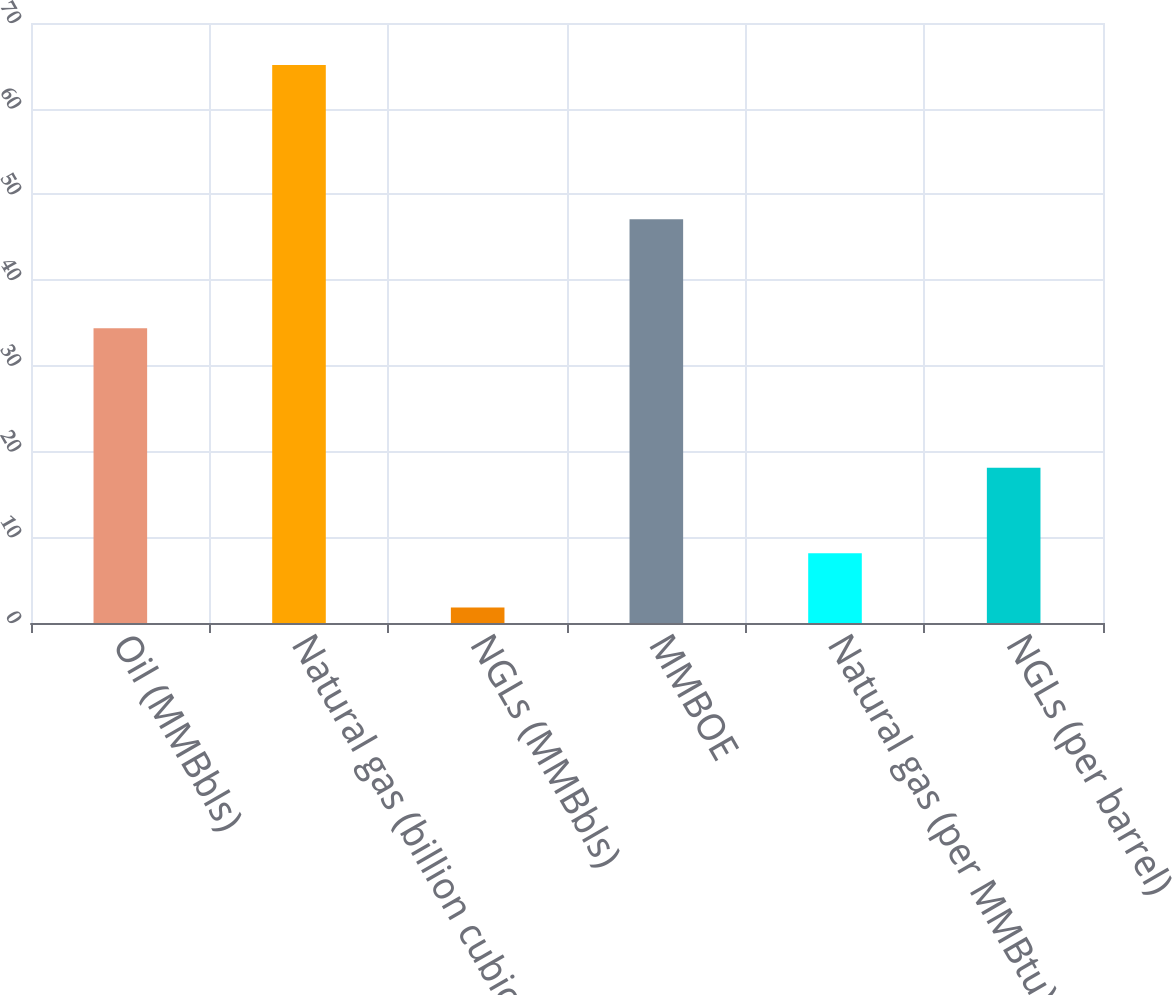<chart> <loc_0><loc_0><loc_500><loc_500><bar_chart><fcel>Oil (MMBbls)<fcel>Natural gas (billion cubic<fcel>NGLs (MMBbls)<fcel>MMBOE<fcel>Natural gas (per MMBtu)<fcel>NGLs (per barrel)<nl><fcel>34.4<fcel>65.1<fcel>1.8<fcel>47.1<fcel>8.13<fcel>18.11<nl></chart> 